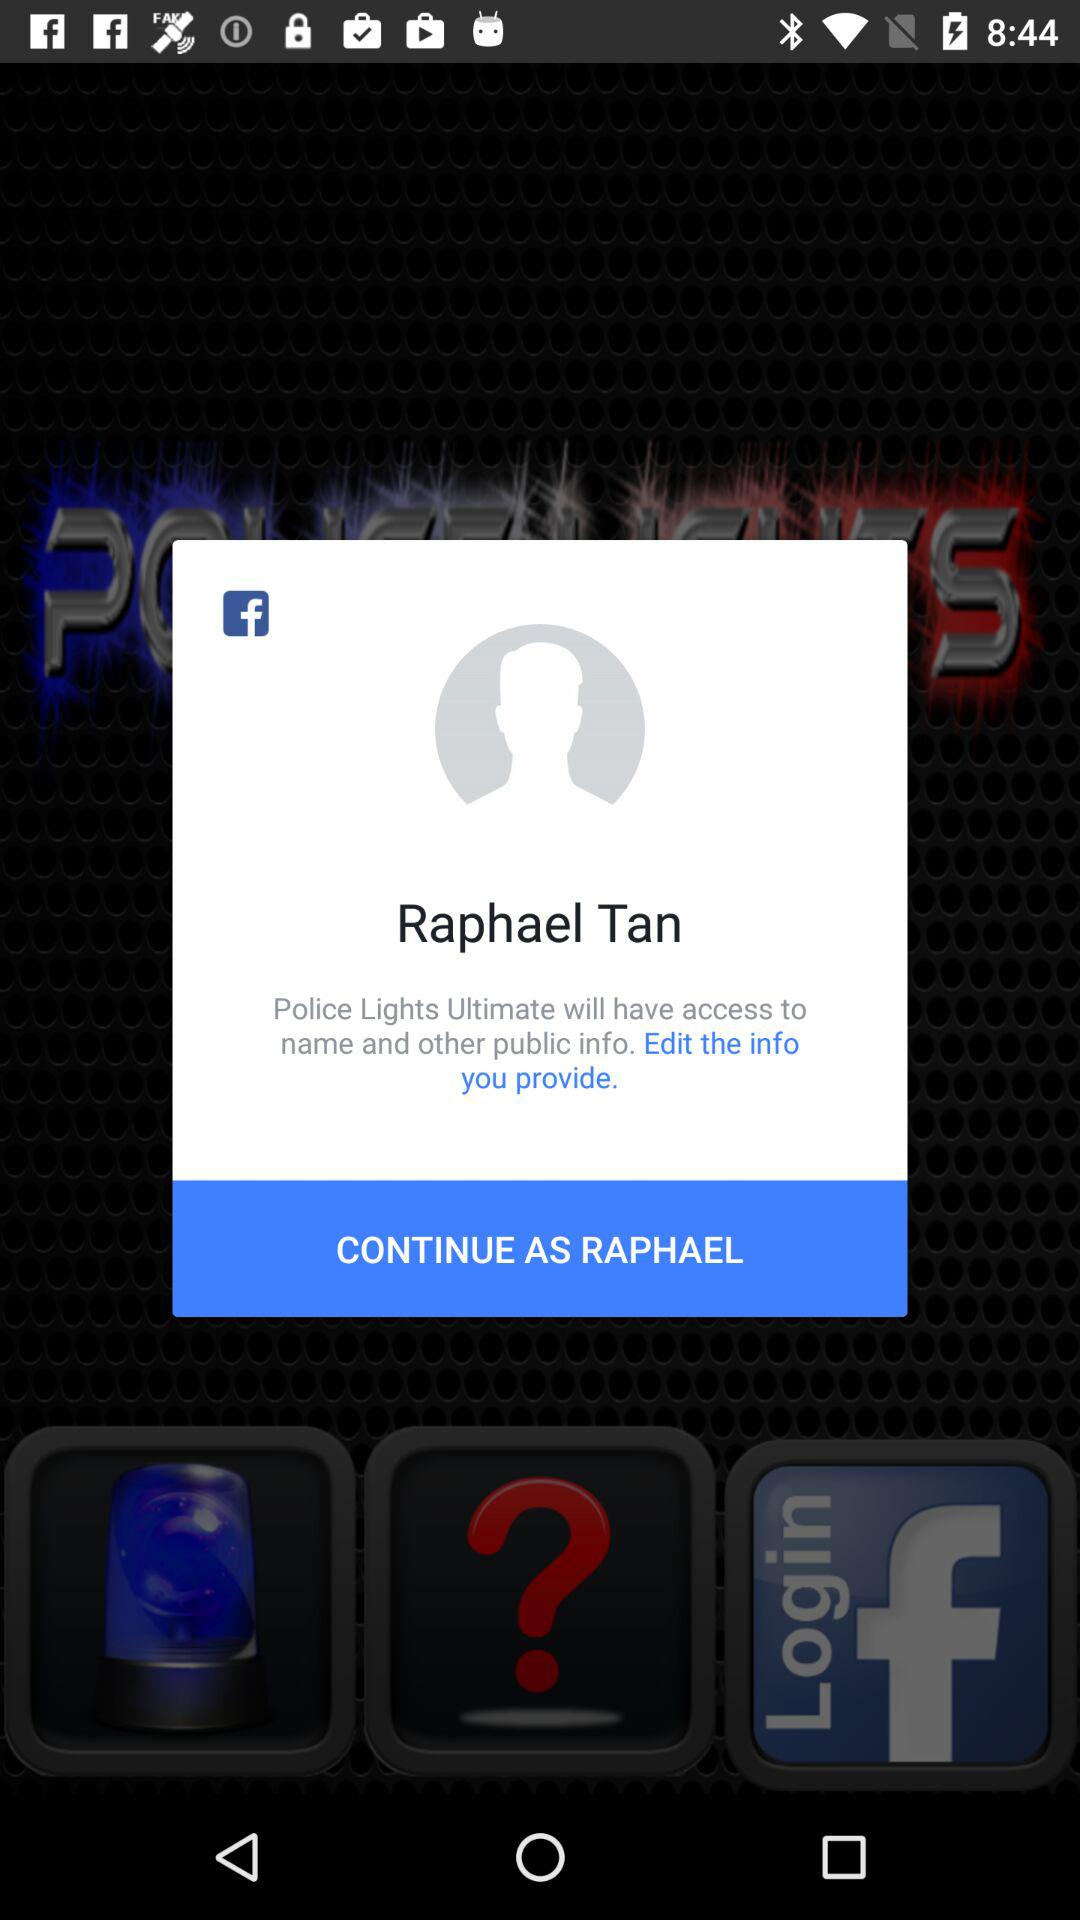What is the name of the user? The name of the user is Raphael Tan. 